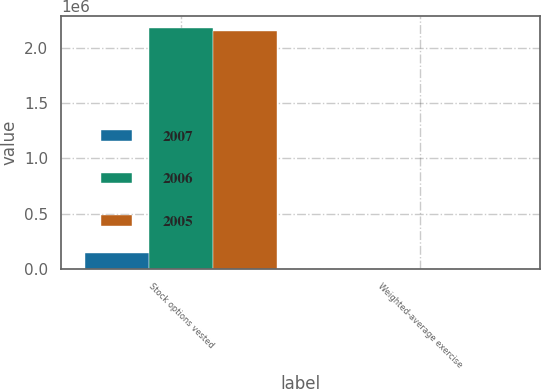Convert chart to OTSL. <chart><loc_0><loc_0><loc_500><loc_500><stacked_bar_chart><ecel><fcel>Stock options vested<fcel>Weighted-average exercise<nl><fcel>2007<fcel>144726<fcel>46.92<nl><fcel>2006<fcel>2.17531e+06<fcel>40.1<nl><fcel>2005<fcel>2.14748e+06<fcel>38.55<nl></chart> 